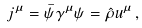Convert formula to latex. <formula><loc_0><loc_0><loc_500><loc_500>j ^ { \mu } = \bar { \psi } \gamma ^ { \mu } \psi = \hat { \rho } u ^ { \mu } \, ,</formula> 